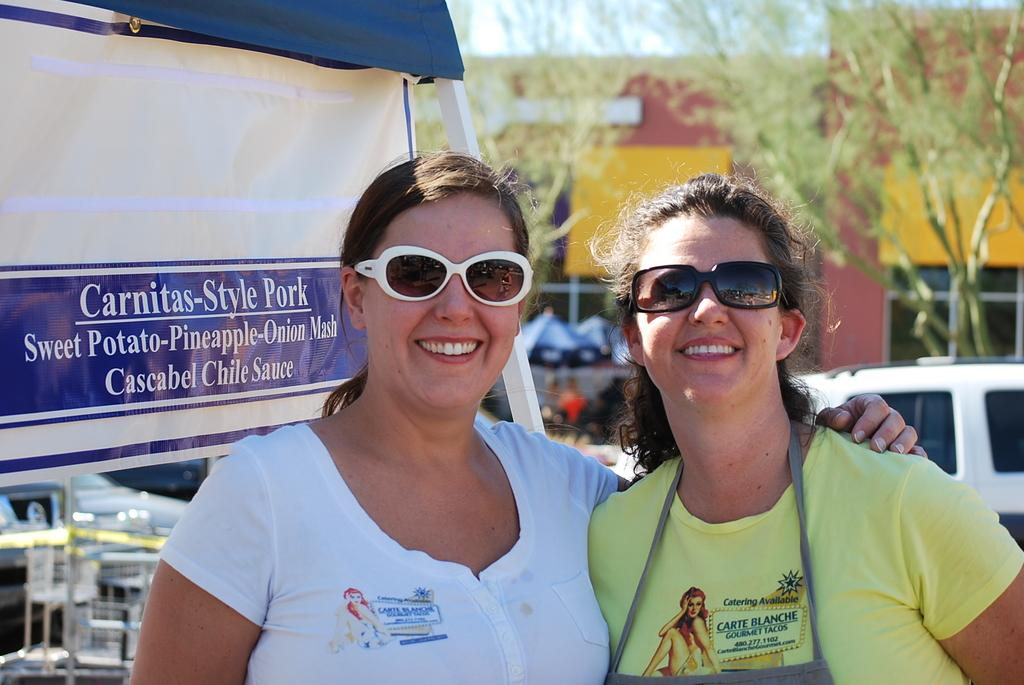How many women are in the image? There are two women in the image. What expression do the women have? The women are smiling. What are the women wearing that covers their eyes? The women are wearing goggles. What can be seen in the background of the image? There is a banner, vehicles, umbrellas, trees, a building, and the sky visible in the background of the image. What type of collar can be seen on the women in the image? There is no collar visible on the women in the image; they are wearing goggles. What test is being conducted in the image? There is no test being conducted in the image; the women are simply wearing goggles and smiling. 